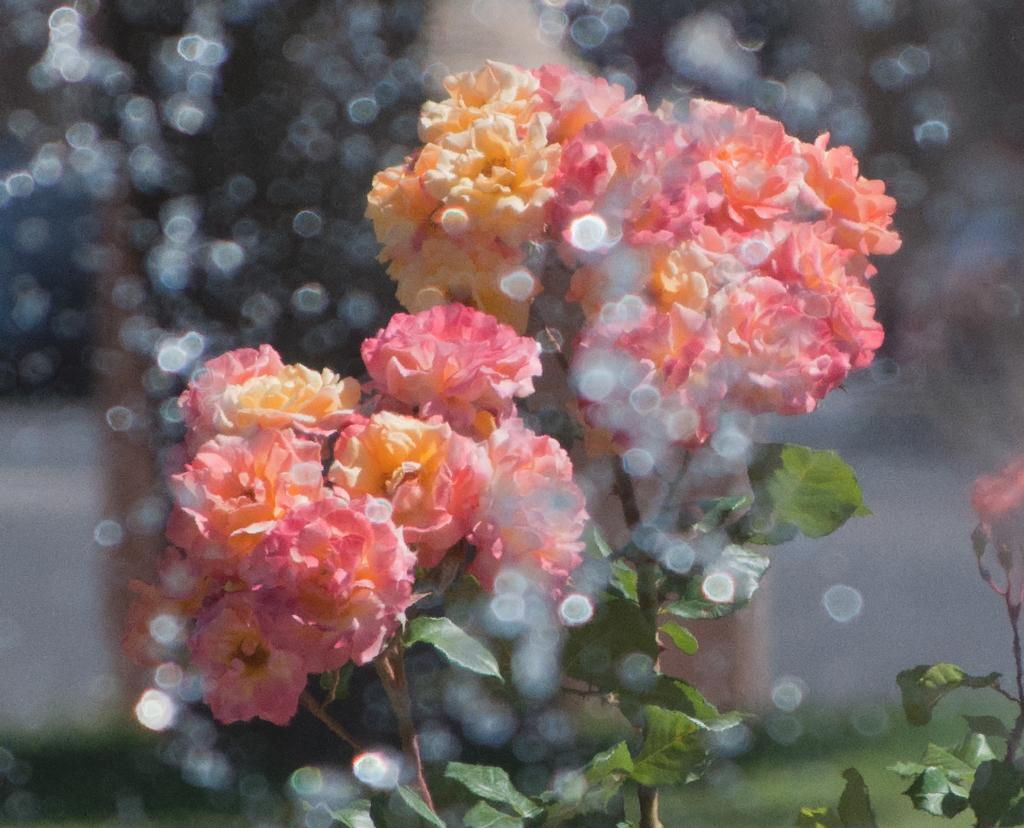What can be seen in the foreground of the image? There are flowers and a plant in the foreground of the image. Are there any other plants visible in the image? Yes, there appears to be another plant in the bottom right side of the image. How would you describe the background of the image? The background of the image is blurred. What type of polish is being applied to the flowers in the image? There is no indication in the image that any polish is being applied to the flowers. 